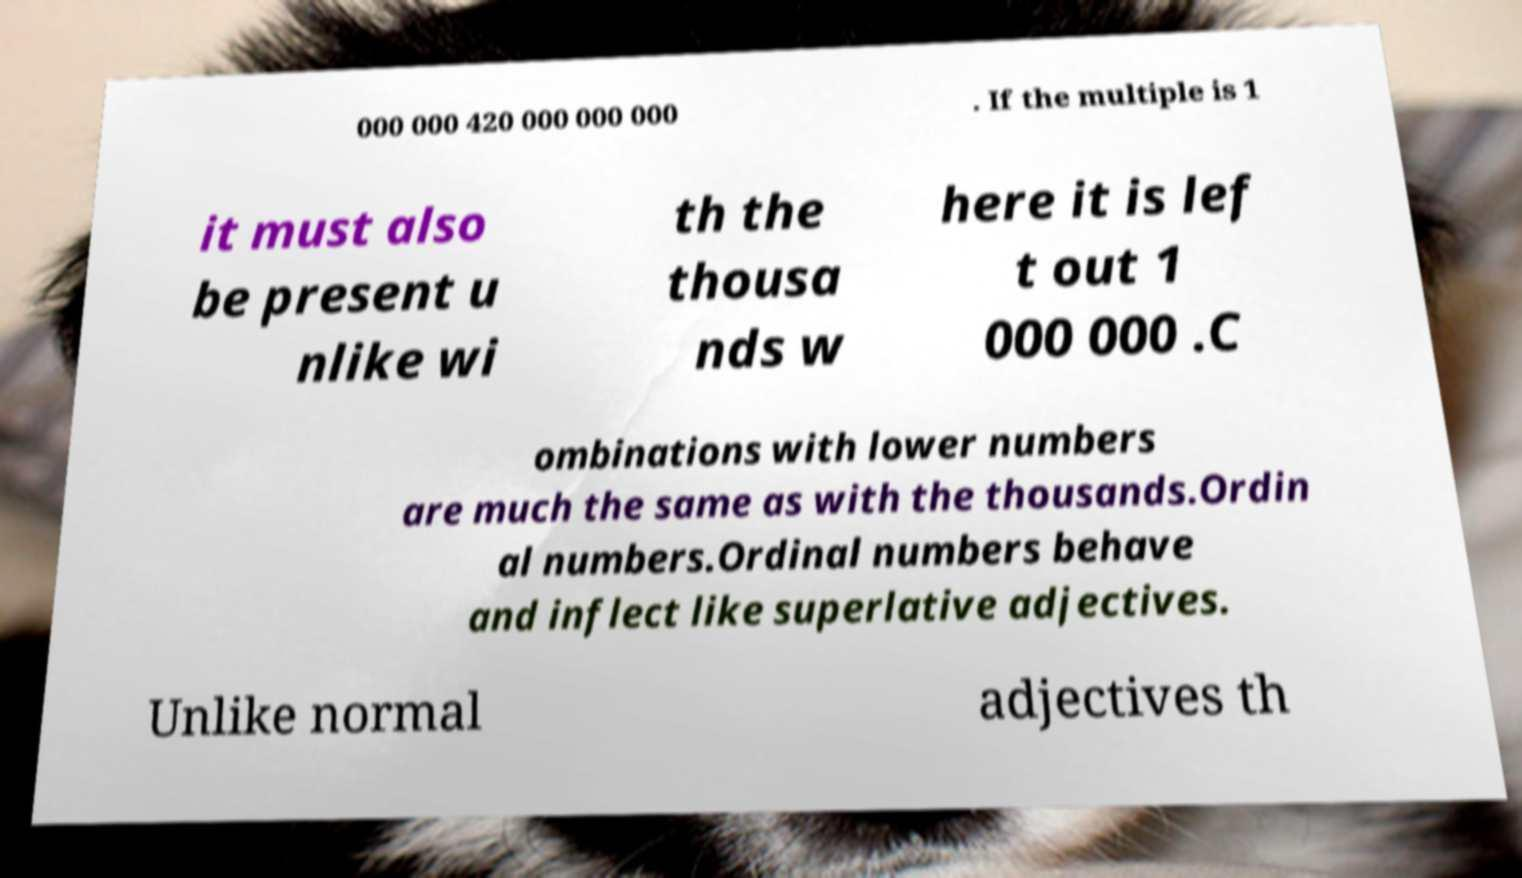For documentation purposes, I need the text within this image transcribed. Could you provide that? 000 000 420 000 000 000 . If the multiple is 1 it must also be present u nlike wi th the thousa nds w here it is lef t out 1 000 000 .C ombinations with lower numbers are much the same as with the thousands.Ordin al numbers.Ordinal numbers behave and inflect like superlative adjectives. Unlike normal adjectives th 